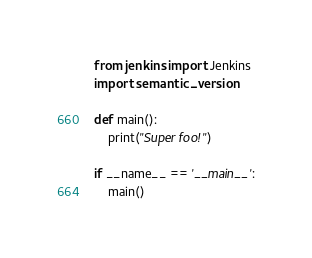<code> <loc_0><loc_0><loc_500><loc_500><_Python_>from jenkins import Jenkins
import semantic_version

def main():
    print("Super foo!")

if __name__ == '__main__':
    main()
</code> 